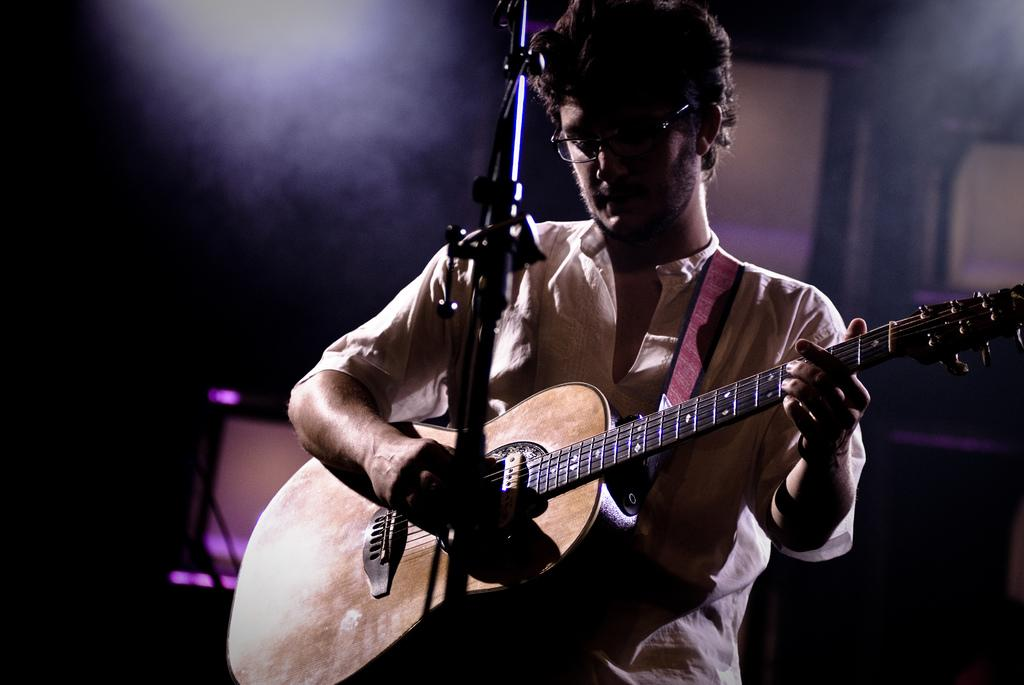What is the man in the image doing? The man is playing guitar. What is the man wearing on his upper body? The man is wearing a white shirt. Are there any accessories visible on the man? Yes, the man is wearing glasses. What object is in front of the man? There is a microphone in front of the man. Can you see a robin perched on the guitar in the image? No, there is no robin present in the image. What type of spoon is the man using to play the guitar? The man is not using a spoon to play the guitar; he is using his hands. 